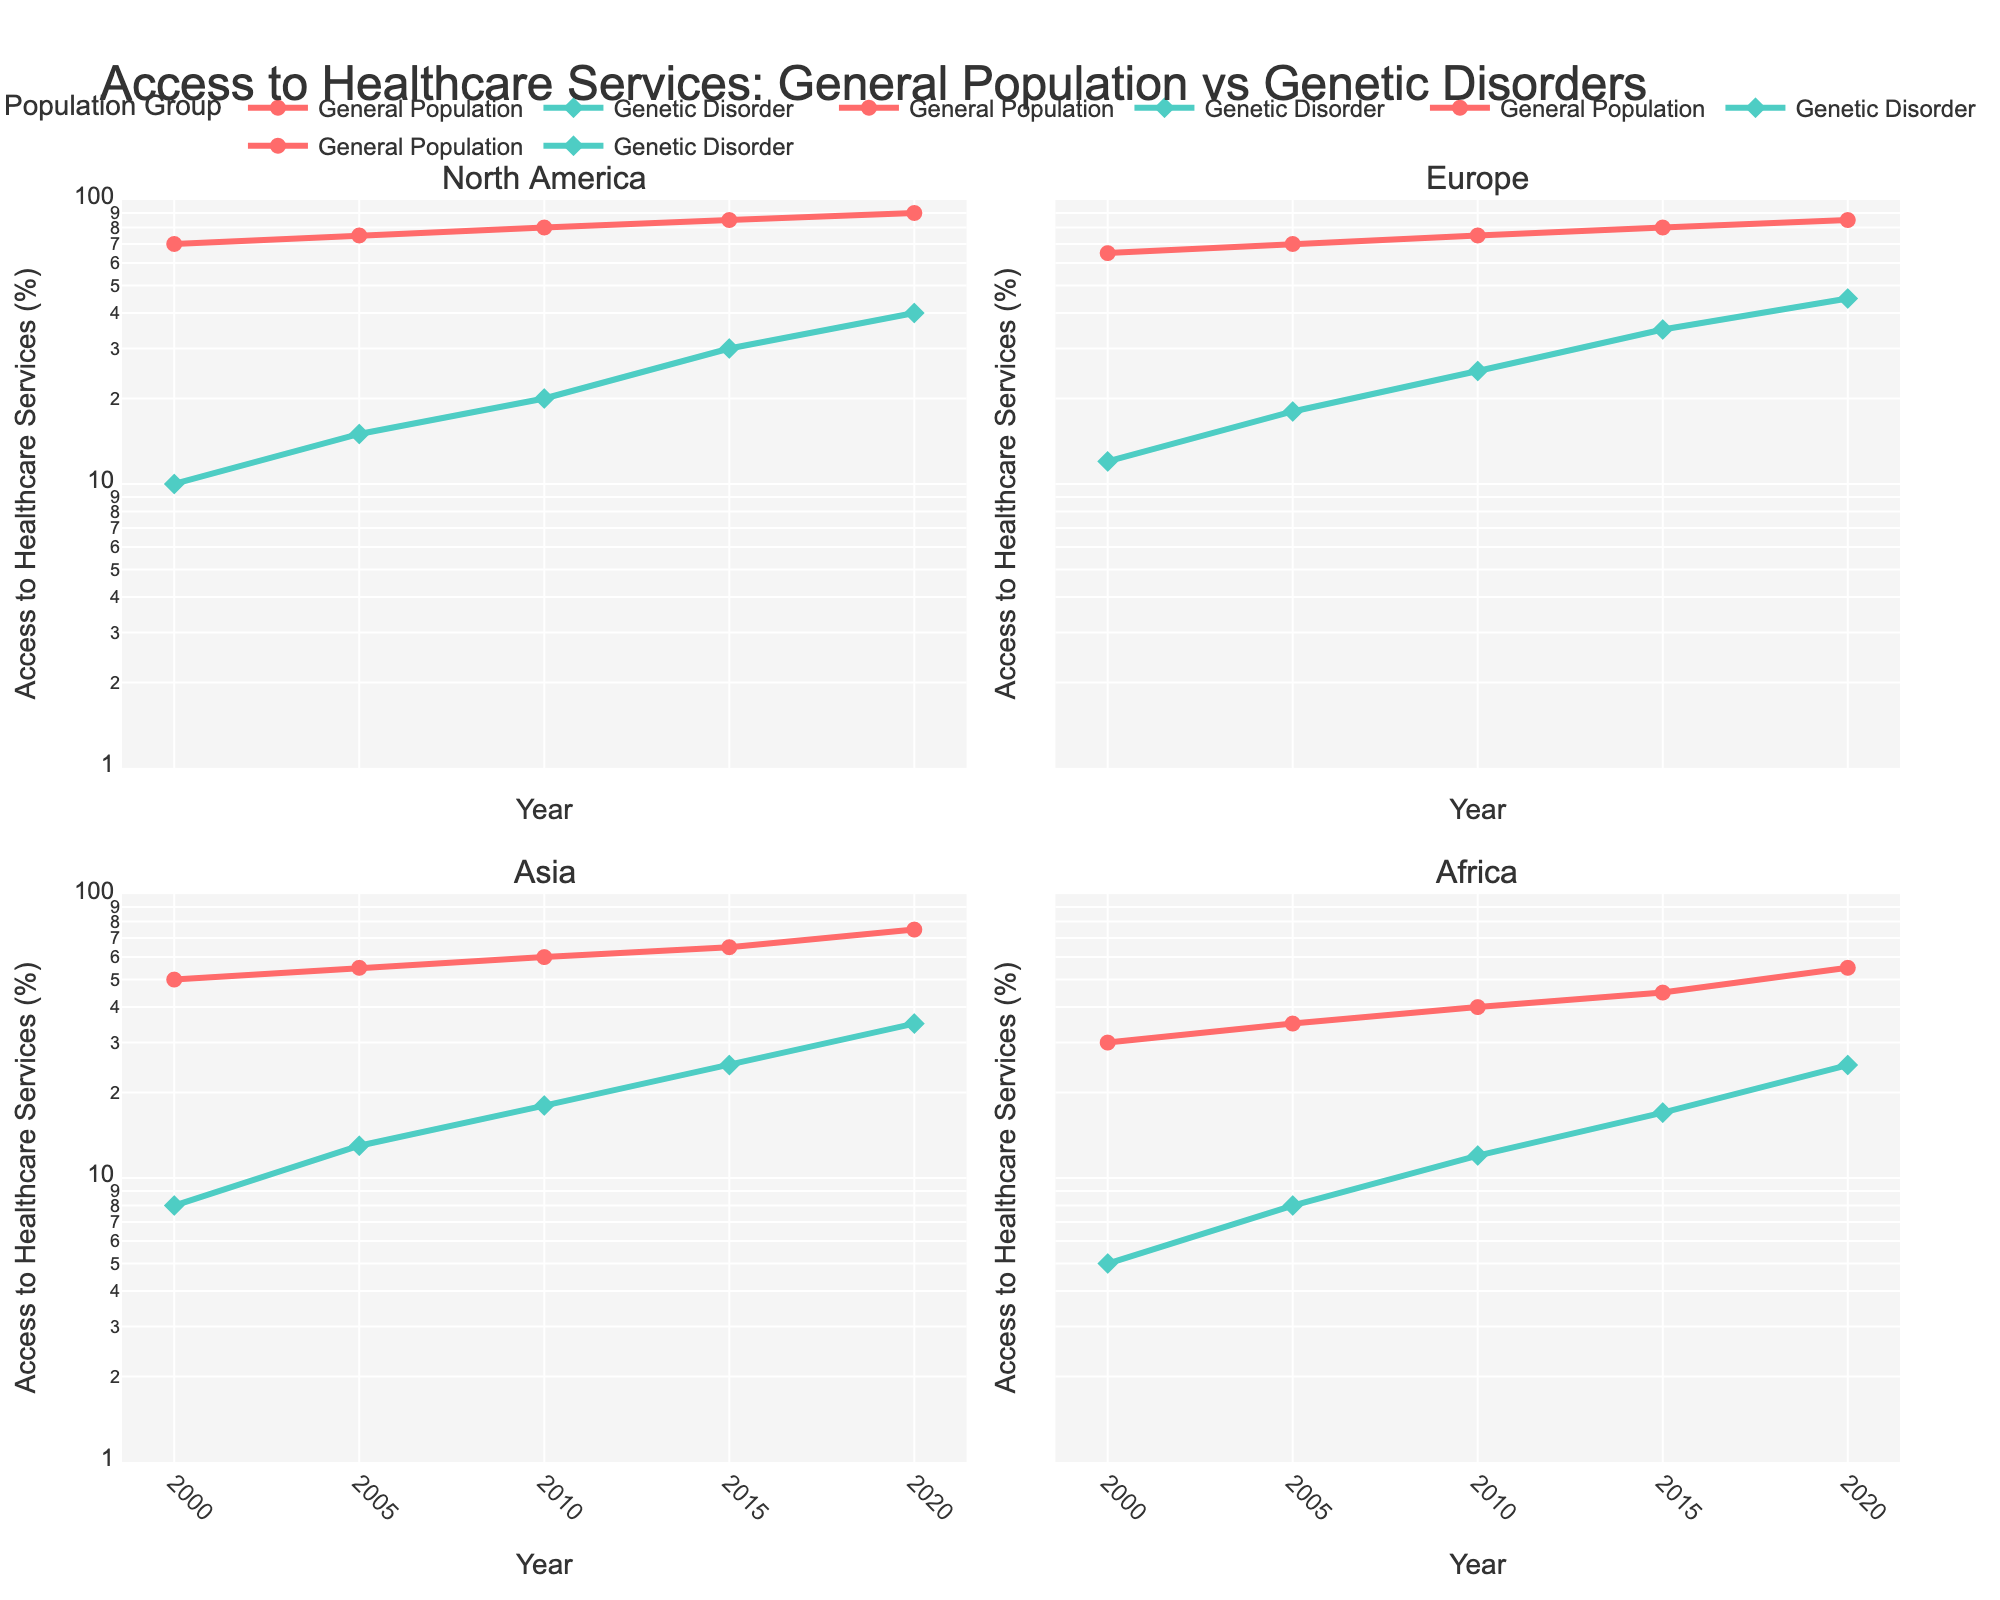What's the title of the figure? The title is usually found at the top of the figure. In this case, it states the overall theme or purpose of the plot.
Answer: Access to Healthcare Services: General Population vs Genetic Disorders What is the scale type used for the y-axis in these plots? By inspecting the y-axis, you can see that the scale increments exponentially rather than linearly, indicating a logarithmic scale.
Answer: Logarithmic Which region shows the greatest increase in healthcare access for individuals with genetic disorders from 2000 to 2020? To determine this, compare the starting and ending values for genetic disorder access in each region and identify the region with the largest difference. North America goes from 10 to 40, Europe from 12 to 45, Asia from 8 to 35, and Africa from 5 to 25.
Answer: Europe In which year did individuals with genetic disorders in North America have the same access level as the general population in Africa? By looking at the figures for both groups and years, match the year when North America's genetic disorder access coincides with Africa's general population access. North America reaches a level of 25% in 2015, which is the same as Africa's general population in 2020.
Answer: 2015 How does the access to healthcare for the general population in Asia in 2010 compare to that in Africa? Looking at the 2010 values for general population access in both regions, Asia shows 60% and Africa shows 40%.
Answer: Higher Which region had the lowest percentage increase in healthcare access for the general population from 2000 to 2020? Calculate the difference between the starting and ending values for the general population in each region and find the smallest one. North America's increase is 20%, Europe’s is 20%, Asia's is 25%, and Africa's is 25%.
Answer: North America and Europe Did healthcare access for individuals with genetic disorders in any region surpass the general population's access in another region? Compare the highest achieved access levels for genetic disorders in each region with the lowest and other values for the general population across regions. No, the highest for genetic disorders is Europe at 45%, which is still below the lowest general population access in North America at 70%.
Answer: No What is the range of years covered by the plot? Look at the x-axis, which shows the range of years covered in the plot for each subplot.
Answer: 2000 to 2020 Which subplot shows the smallest gap between the general population and individuals with genetic disorders in the year 2020? Assess the data points for 2020 in each subplot and measure the distance between the two lines. Europe has the data points 85% for the general population and 45% for genetic disorders.
Answer: Europe How did the access to healthcare change for the general population in Africa from 2010 to 2020? Compare the values from 2010 to 2020 for general population access in Africa, showing an increase from 40% to 55%.
Answer: Increased 